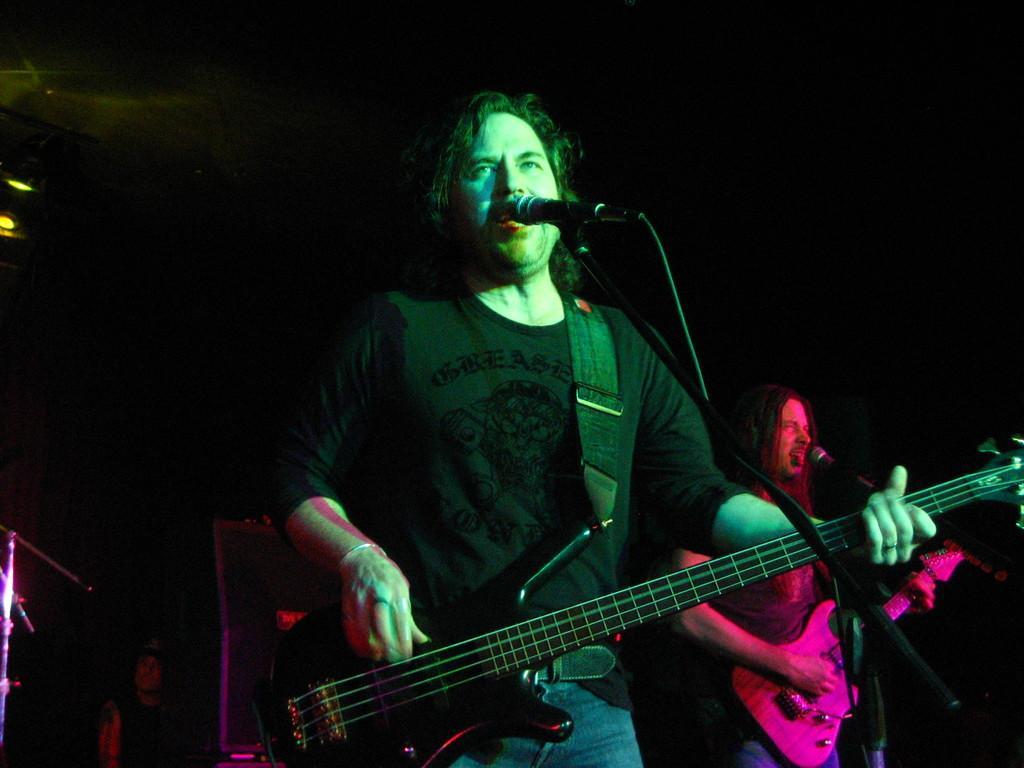Describe this image in one or two sentences. In this image we can see this two persons are holding guitar in their hands and playing it. They are singing through the mic in front of them. There is a dark background. 